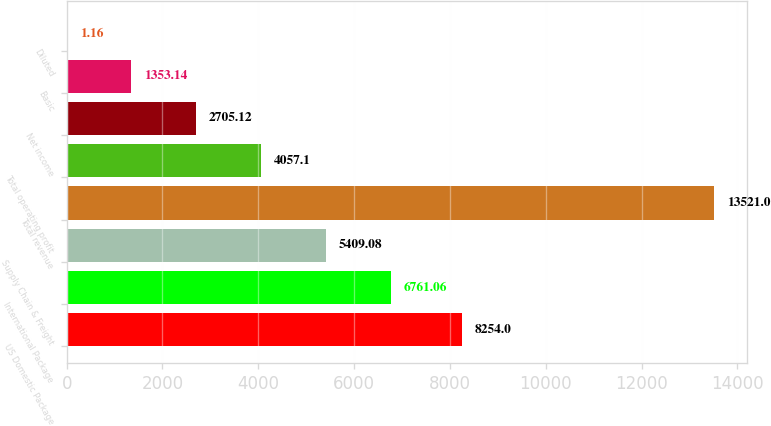<chart> <loc_0><loc_0><loc_500><loc_500><bar_chart><fcel>US Domestic Package<fcel>International Package<fcel>Supply Chain & Freight<fcel>Total revenue<fcel>Total operating profit<fcel>Net income<fcel>Basic<fcel>Diluted<nl><fcel>8254<fcel>6761.06<fcel>5409.08<fcel>13521<fcel>4057.1<fcel>2705.12<fcel>1353.14<fcel>1.16<nl></chart> 